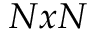Convert formula to latex. <formula><loc_0><loc_0><loc_500><loc_500>N x N</formula> 